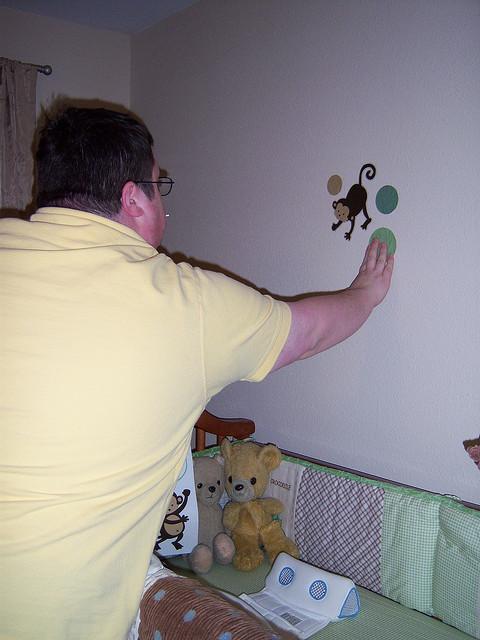How many teddy bears can be seen?
Give a very brief answer. 2. 